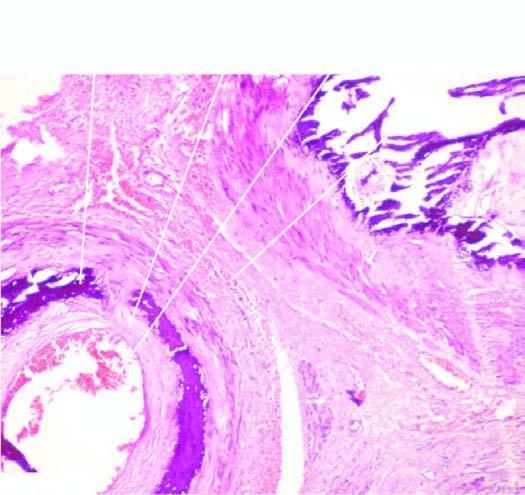what is there exclusively in the tunica media unassociated with any significant inflammation?
Answer the question using a single word or phrase. Calcification 